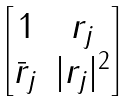Convert formula to latex. <formula><loc_0><loc_0><loc_500><loc_500>\begin{bmatrix} 1 & r _ { j } \\ \bar { r } _ { j } & | r _ { j } | ^ { 2 } \end{bmatrix}</formula> 